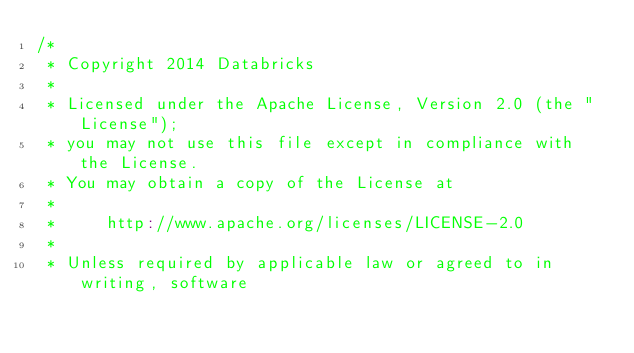<code> <loc_0><loc_0><loc_500><loc_500><_Scala_>/*
 * Copyright 2014 Databricks
 *
 * Licensed under the Apache License, Version 2.0 (the "License");
 * you may not use this file except in compliance with the License.
 * You may obtain a copy of the License at
 *
 *     http://www.apache.org/licenses/LICENSE-2.0
 *
 * Unless required by applicable law or agreed to in writing, software</code> 